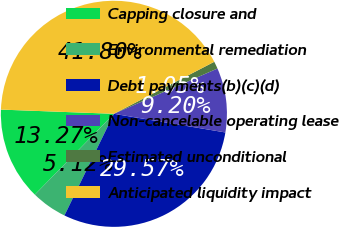Convert chart. <chart><loc_0><loc_0><loc_500><loc_500><pie_chart><fcel>Capping closure and<fcel>Environmental remediation<fcel>Debt payments(b)(c)(d)<fcel>Non-cancelable operating lease<fcel>Estimated unconditional<fcel>Anticipated liquidity impact<nl><fcel>13.27%<fcel>5.12%<fcel>29.57%<fcel>9.2%<fcel>1.05%<fcel>41.8%<nl></chart> 